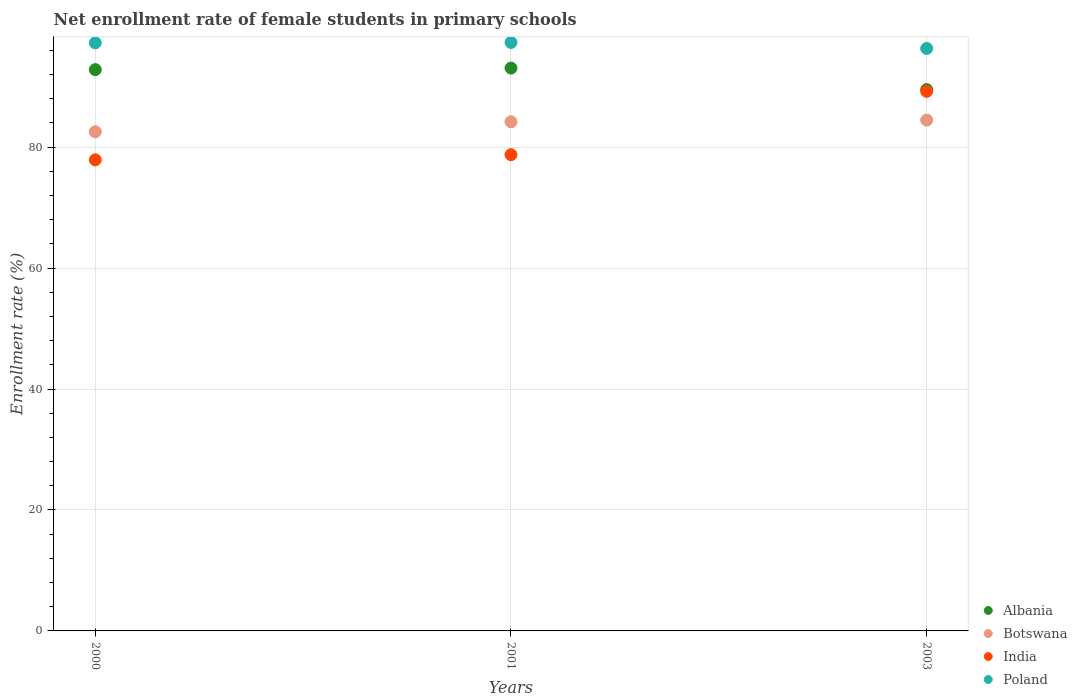What is the net enrollment rate of female students in primary schools in India in 2000?
Keep it short and to the point. 77.9. Across all years, what is the maximum net enrollment rate of female students in primary schools in Albania?
Keep it short and to the point. 93.07. Across all years, what is the minimum net enrollment rate of female students in primary schools in Albania?
Offer a very short reply. 89.51. In which year was the net enrollment rate of female students in primary schools in India minimum?
Provide a succinct answer. 2000. What is the total net enrollment rate of female students in primary schools in Albania in the graph?
Give a very brief answer. 275.4. What is the difference between the net enrollment rate of female students in primary schools in Botswana in 2000 and that in 2001?
Keep it short and to the point. -1.65. What is the difference between the net enrollment rate of female students in primary schools in Poland in 2000 and the net enrollment rate of female students in primary schools in Albania in 2001?
Provide a succinct answer. 4.18. What is the average net enrollment rate of female students in primary schools in Botswana per year?
Give a very brief answer. 83.74. In the year 2001, what is the difference between the net enrollment rate of female students in primary schools in Albania and net enrollment rate of female students in primary schools in India?
Provide a succinct answer. 14.32. What is the ratio of the net enrollment rate of female students in primary schools in India in 2000 to that in 2001?
Provide a short and direct response. 0.99. Is the net enrollment rate of female students in primary schools in Poland in 2000 less than that in 2003?
Provide a succinct answer. No. Is the difference between the net enrollment rate of female students in primary schools in Albania in 2000 and 2001 greater than the difference between the net enrollment rate of female students in primary schools in India in 2000 and 2001?
Offer a very short reply. Yes. What is the difference between the highest and the second highest net enrollment rate of female students in primary schools in Poland?
Keep it short and to the point. 0.06. What is the difference between the highest and the lowest net enrollment rate of female students in primary schools in India?
Make the answer very short. 11.32. In how many years, is the net enrollment rate of female students in primary schools in Botswana greater than the average net enrollment rate of female students in primary schools in Botswana taken over all years?
Make the answer very short. 2. Is it the case that in every year, the sum of the net enrollment rate of female students in primary schools in India and net enrollment rate of female students in primary schools in Botswana  is greater than the net enrollment rate of female students in primary schools in Albania?
Give a very brief answer. Yes. Is the net enrollment rate of female students in primary schools in Poland strictly greater than the net enrollment rate of female students in primary schools in India over the years?
Ensure brevity in your answer.  Yes. How many dotlines are there?
Your answer should be compact. 4. What is the difference between two consecutive major ticks on the Y-axis?
Give a very brief answer. 20. Does the graph contain any zero values?
Make the answer very short. No. Does the graph contain grids?
Ensure brevity in your answer.  Yes. Where does the legend appear in the graph?
Offer a very short reply. Bottom right. How many legend labels are there?
Give a very brief answer. 4. What is the title of the graph?
Your answer should be compact. Net enrollment rate of female students in primary schools. Does "Luxembourg" appear as one of the legend labels in the graph?
Provide a short and direct response. No. What is the label or title of the Y-axis?
Keep it short and to the point. Enrollment rate (%). What is the Enrollment rate (%) in Albania in 2000?
Make the answer very short. 92.82. What is the Enrollment rate (%) of Botswana in 2000?
Your answer should be compact. 82.54. What is the Enrollment rate (%) of India in 2000?
Your response must be concise. 77.9. What is the Enrollment rate (%) in Poland in 2000?
Give a very brief answer. 97.25. What is the Enrollment rate (%) in Albania in 2001?
Keep it short and to the point. 93.07. What is the Enrollment rate (%) of Botswana in 2001?
Provide a short and direct response. 84.19. What is the Enrollment rate (%) in India in 2001?
Offer a very short reply. 78.75. What is the Enrollment rate (%) of Poland in 2001?
Give a very brief answer. 97.31. What is the Enrollment rate (%) in Albania in 2003?
Ensure brevity in your answer.  89.51. What is the Enrollment rate (%) of Botswana in 2003?
Give a very brief answer. 84.47. What is the Enrollment rate (%) in India in 2003?
Offer a very short reply. 89.22. What is the Enrollment rate (%) in Poland in 2003?
Your answer should be very brief. 96.31. Across all years, what is the maximum Enrollment rate (%) of Albania?
Make the answer very short. 93.07. Across all years, what is the maximum Enrollment rate (%) of Botswana?
Make the answer very short. 84.47. Across all years, what is the maximum Enrollment rate (%) in India?
Keep it short and to the point. 89.22. Across all years, what is the maximum Enrollment rate (%) of Poland?
Your response must be concise. 97.31. Across all years, what is the minimum Enrollment rate (%) in Albania?
Make the answer very short. 89.51. Across all years, what is the minimum Enrollment rate (%) of Botswana?
Provide a short and direct response. 82.54. Across all years, what is the minimum Enrollment rate (%) of India?
Give a very brief answer. 77.9. Across all years, what is the minimum Enrollment rate (%) in Poland?
Your response must be concise. 96.31. What is the total Enrollment rate (%) in Albania in the graph?
Give a very brief answer. 275.4. What is the total Enrollment rate (%) of Botswana in the graph?
Keep it short and to the point. 251.21. What is the total Enrollment rate (%) of India in the graph?
Give a very brief answer. 245.88. What is the total Enrollment rate (%) in Poland in the graph?
Your answer should be very brief. 290.88. What is the difference between the Enrollment rate (%) of Albania in 2000 and that in 2001?
Your answer should be very brief. -0.26. What is the difference between the Enrollment rate (%) in Botswana in 2000 and that in 2001?
Your response must be concise. -1.65. What is the difference between the Enrollment rate (%) of India in 2000 and that in 2001?
Your response must be concise. -0.85. What is the difference between the Enrollment rate (%) in Poland in 2000 and that in 2001?
Make the answer very short. -0.06. What is the difference between the Enrollment rate (%) in Albania in 2000 and that in 2003?
Provide a short and direct response. 3.3. What is the difference between the Enrollment rate (%) in Botswana in 2000 and that in 2003?
Ensure brevity in your answer.  -1.93. What is the difference between the Enrollment rate (%) of India in 2000 and that in 2003?
Provide a succinct answer. -11.32. What is the difference between the Enrollment rate (%) in Poland in 2000 and that in 2003?
Offer a terse response. 0.93. What is the difference between the Enrollment rate (%) in Albania in 2001 and that in 2003?
Your answer should be very brief. 3.56. What is the difference between the Enrollment rate (%) of Botswana in 2001 and that in 2003?
Offer a very short reply. -0.28. What is the difference between the Enrollment rate (%) of India in 2001 and that in 2003?
Your response must be concise. -10.47. What is the difference between the Enrollment rate (%) of Albania in 2000 and the Enrollment rate (%) of Botswana in 2001?
Offer a terse response. 8.62. What is the difference between the Enrollment rate (%) in Albania in 2000 and the Enrollment rate (%) in India in 2001?
Keep it short and to the point. 14.06. What is the difference between the Enrollment rate (%) of Albania in 2000 and the Enrollment rate (%) of Poland in 2001?
Provide a short and direct response. -4.5. What is the difference between the Enrollment rate (%) of Botswana in 2000 and the Enrollment rate (%) of India in 2001?
Provide a succinct answer. 3.79. What is the difference between the Enrollment rate (%) of Botswana in 2000 and the Enrollment rate (%) of Poland in 2001?
Give a very brief answer. -14.77. What is the difference between the Enrollment rate (%) of India in 2000 and the Enrollment rate (%) of Poland in 2001?
Your response must be concise. -19.41. What is the difference between the Enrollment rate (%) of Albania in 2000 and the Enrollment rate (%) of Botswana in 2003?
Ensure brevity in your answer.  8.34. What is the difference between the Enrollment rate (%) of Albania in 2000 and the Enrollment rate (%) of India in 2003?
Provide a succinct answer. 3.59. What is the difference between the Enrollment rate (%) in Albania in 2000 and the Enrollment rate (%) in Poland in 2003?
Your response must be concise. -3.5. What is the difference between the Enrollment rate (%) in Botswana in 2000 and the Enrollment rate (%) in India in 2003?
Provide a succinct answer. -6.68. What is the difference between the Enrollment rate (%) in Botswana in 2000 and the Enrollment rate (%) in Poland in 2003?
Offer a terse response. -13.77. What is the difference between the Enrollment rate (%) in India in 2000 and the Enrollment rate (%) in Poland in 2003?
Provide a short and direct response. -18.41. What is the difference between the Enrollment rate (%) of Albania in 2001 and the Enrollment rate (%) of Botswana in 2003?
Your answer should be compact. 8.6. What is the difference between the Enrollment rate (%) of Albania in 2001 and the Enrollment rate (%) of India in 2003?
Provide a succinct answer. 3.85. What is the difference between the Enrollment rate (%) in Albania in 2001 and the Enrollment rate (%) in Poland in 2003?
Offer a terse response. -3.24. What is the difference between the Enrollment rate (%) of Botswana in 2001 and the Enrollment rate (%) of India in 2003?
Offer a terse response. -5.03. What is the difference between the Enrollment rate (%) of Botswana in 2001 and the Enrollment rate (%) of Poland in 2003?
Offer a terse response. -12.12. What is the difference between the Enrollment rate (%) of India in 2001 and the Enrollment rate (%) of Poland in 2003?
Provide a succinct answer. -17.56. What is the average Enrollment rate (%) in Albania per year?
Ensure brevity in your answer.  91.8. What is the average Enrollment rate (%) of Botswana per year?
Offer a very short reply. 83.74. What is the average Enrollment rate (%) of India per year?
Your response must be concise. 81.96. What is the average Enrollment rate (%) in Poland per year?
Your answer should be compact. 96.96. In the year 2000, what is the difference between the Enrollment rate (%) in Albania and Enrollment rate (%) in Botswana?
Offer a very short reply. 10.27. In the year 2000, what is the difference between the Enrollment rate (%) in Albania and Enrollment rate (%) in India?
Offer a very short reply. 14.91. In the year 2000, what is the difference between the Enrollment rate (%) of Albania and Enrollment rate (%) of Poland?
Give a very brief answer. -4.43. In the year 2000, what is the difference between the Enrollment rate (%) in Botswana and Enrollment rate (%) in India?
Make the answer very short. 4.64. In the year 2000, what is the difference between the Enrollment rate (%) of Botswana and Enrollment rate (%) of Poland?
Give a very brief answer. -14.71. In the year 2000, what is the difference between the Enrollment rate (%) of India and Enrollment rate (%) of Poland?
Make the answer very short. -19.35. In the year 2001, what is the difference between the Enrollment rate (%) of Albania and Enrollment rate (%) of Botswana?
Offer a very short reply. 8.88. In the year 2001, what is the difference between the Enrollment rate (%) of Albania and Enrollment rate (%) of India?
Provide a succinct answer. 14.32. In the year 2001, what is the difference between the Enrollment rate (%) in Albania and Enrollment rate (%) in Poland?
Your answer should be very brief. -4.24. In the year 2001, what is the difference between the Enrollment rate (%) of Botswana and Enrollment rate (%) of India?
Provide a short and direct response. 5.44. In the year 2001, what is the difference between the Enrollment rate (%) in Botswana and Enrollment rate (%) in Poland?
Give a very brief answer. -13.12. In the year 2001, what is the difference between the Enrollment rate (%) of India and Enrollment rate (%) of Poland?
Offer a very short reply. -18.56. In the year 2003, what is the difference between the Enrollment rate (%) in Albania and Enrollment rate (%) in Botswana?
Offer a terse response. 5.04. In the year 2003, what is the difference between the Enrollment rate (%) of Albania and Enrollment rate (%) of India?
Offer a very short reply. 0.29. In the year 2003, what is the difference between the Enrollment rate (%) in Albania and Enrollment rate (%) in Poland?
Your answer should be compact. -6.8. In the year 2003, what is the difference between the Enrollment rate (%) in Botswana and Enrollment rate (%) in India?
Give a very brief answer. -4.75. In the year 2003, what is the difference between the Enrollment rate (%) in Botswana and Enrollment rate (%) in Poland?
Make the answer very short. -11.84. In the year 2003, what is the difference between the Enrollment rate (%) of India and Enrollment rate (%) of Poland?
Your answer should be very brief. -7.09. What is the ratio of the Enrollment rate (%) of Botswana in 2000 to that in 2001?
Your answer should be compact. 0.98. What is the ratio of the Enrollment rate (%) of India in 2000 to that in 2001?
Your answer should be compact. 0.99. What is the ratio of the Enrollment rate (%) of Albania in 2000 to that in 2003?
Offer a very short reply. 1.04. What is the ratio of the Enrollment rate (%) of Botswana in 2000 to that in 2003?
Offer a very short reply. 0.98. What is the ratio of the Enrollment rate (%) in India in 2000 to that in 2003?
Make the answer very short. 0.87. What is the ratio of the Enrollment rate (%) of Poland in 2000 to that in 2003?
Offer a terse response. 1.01. What is the ratio of the Enrollment rate (%) of Albania in 2001 to that in 2003?
Offer a terse response. 1.04. What is the ratio of the Enrollment rate (%) of India in 2001 to that in 2003?
Offer a terse response. 0.88. What is the ratio of the Enrollment rate (%) of Poland in 2001 to that in 2003?
Ensure brevity in your answer.  1.01. What is the difference between the highest and the second highest Enrollment rate (%) in Albania?
Keep it short and to the point. 0.26. What is the difference between the highest and the second highest Enrollment rate (%) in Botswana?
Offer a very short reply. 0.28. What is the difference between the highest and the second highest Enrollment rate (%) of India?
Your answer should be very brief. 10.47. What is the difference between the highest and the second highest Enrollment rate (%) of Poland?
Ensure brevity in your answer.  0.06. What is the difference between the highest and the lowest Enrollment rate (%) of Albania?
Provide a short and direct response. 3.56. What is the difference between the highest and the lowest Enrollment rate (%) in Botswana?
Keep it short and to the point. 1.93. What is the difference between the highest and the lowest Enrollment rate (%) of India?
Provide a succinct answer. 11.32. 